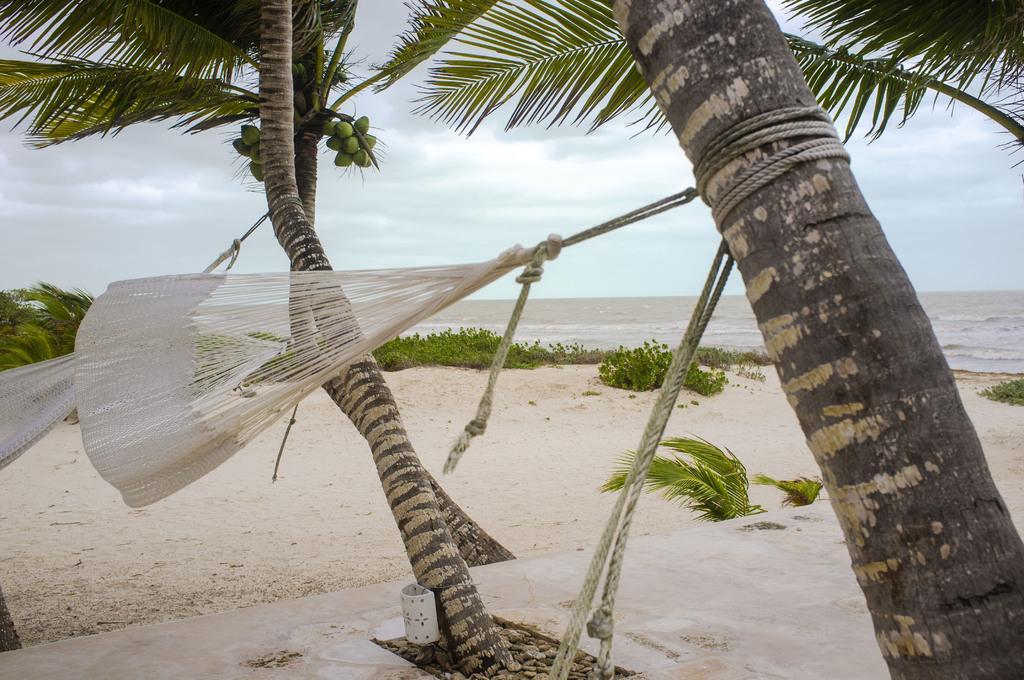In one or two sentences, can you explain what this image depicts? In this image two swings are tied to the trees. Trees are having few coconuts to it. Few plants are on the land. Middle of the image there is water. Top of the image there is sky. 